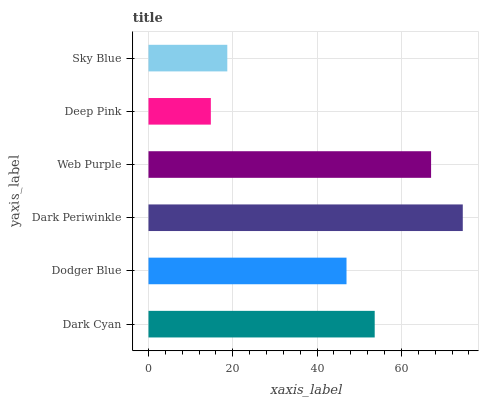Is Deep Pink the minimum?
Answer yes or no. Yes. Is Dark Periwinkle the maximum?
Answer yes or no. Yes. Is Dodger Blue the minimum?
Answer yes or no. No. Is Dodger Blue the maximum?
Answer yes or no. No. Is Dark Cyan greater than Dodger Blue?
Answer yes or no. Yes. Is Dodger Blue less than Dark Cyan?
Answer yes or no. Yes. Is Dodger Blue greater than Dark Cyan?
Answer yes or no. No. Is Dark Cyan less than Dodger Blue?
Answer yes or no. No. Is Dark Cyan the high median?
Answer yes or no. Yes. Is Dodger Blue the low median?
Answer yes or no. Yes. Is Dark Periwinkle the high median?
Answer yes or no. No. Is Web Purple the low median?
Answer yes or no. No. 